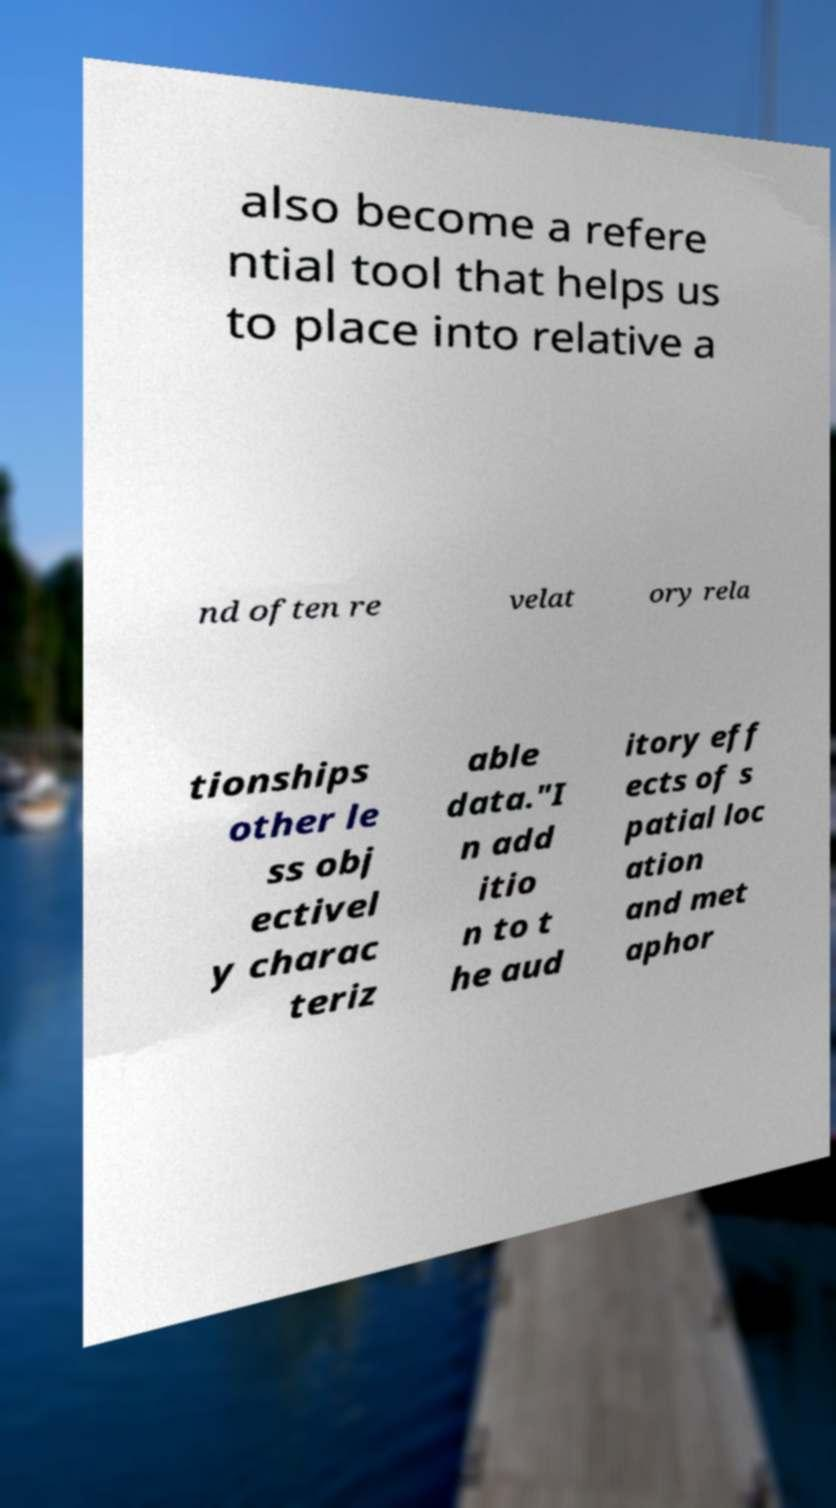For documentation purposes, I need the text within this image transcribed. Could you provide that? also become a refere ntial tool that helps us to place into relative a nd often re velat ory rela tionships other le ss obj ectivel y charac teriz able data."I n add itio n to t he aud itory eff ects of s patial loc ation and met aphor 